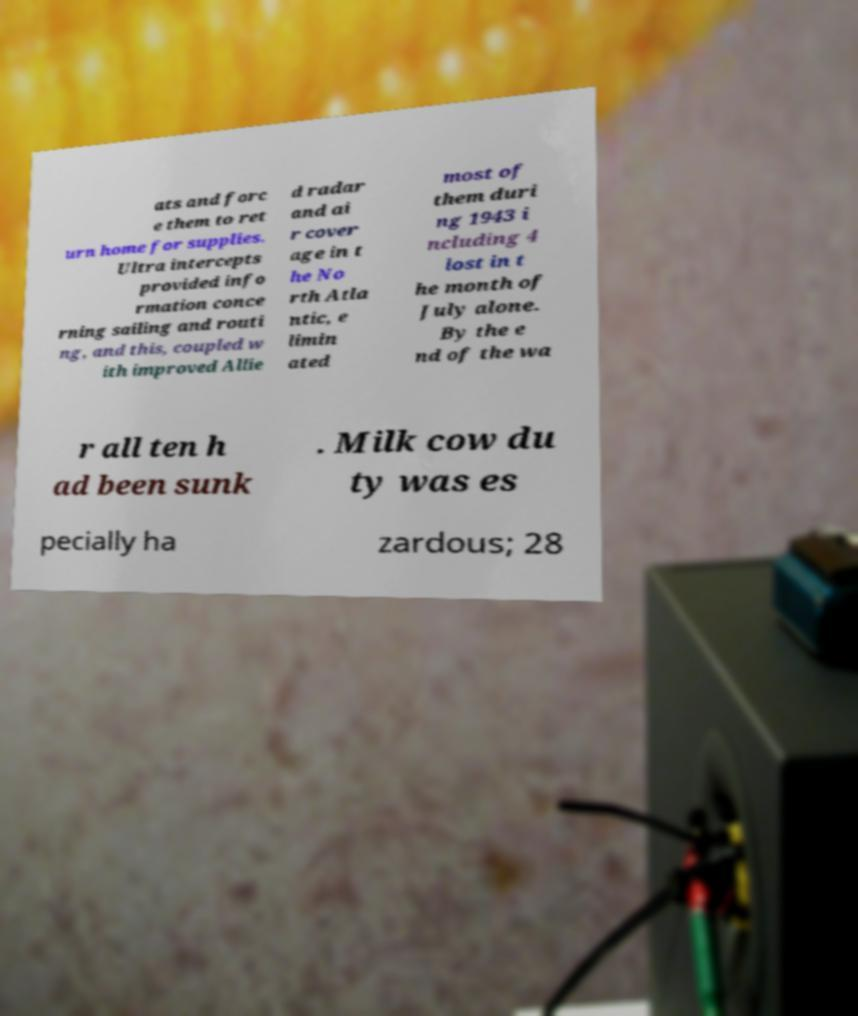Could you extract and type out the text from this image? ats and forc e them to ret urn home for supplies. Ultra intercepts provided info rmation conce rning sailing and routi ng, and this, coupled w ith improved Allie d radar and ai r cover age in t he No rth Atla ntic, e limin ated most of them duri ng 1943 i ncluding 4 lost in t he month of July alone. By the e nd of the wa r all ten h ad been sunk . Milk cow du ty was es pecially ha zardous; 28 